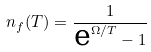Convert formula to latex. <formula><loc_0><loc_0><loc_500><loc_500>n _ { f } ( T ) = \frac { 1 } { \text {e} ^ { \Omega / T } - 1 }</formula> 